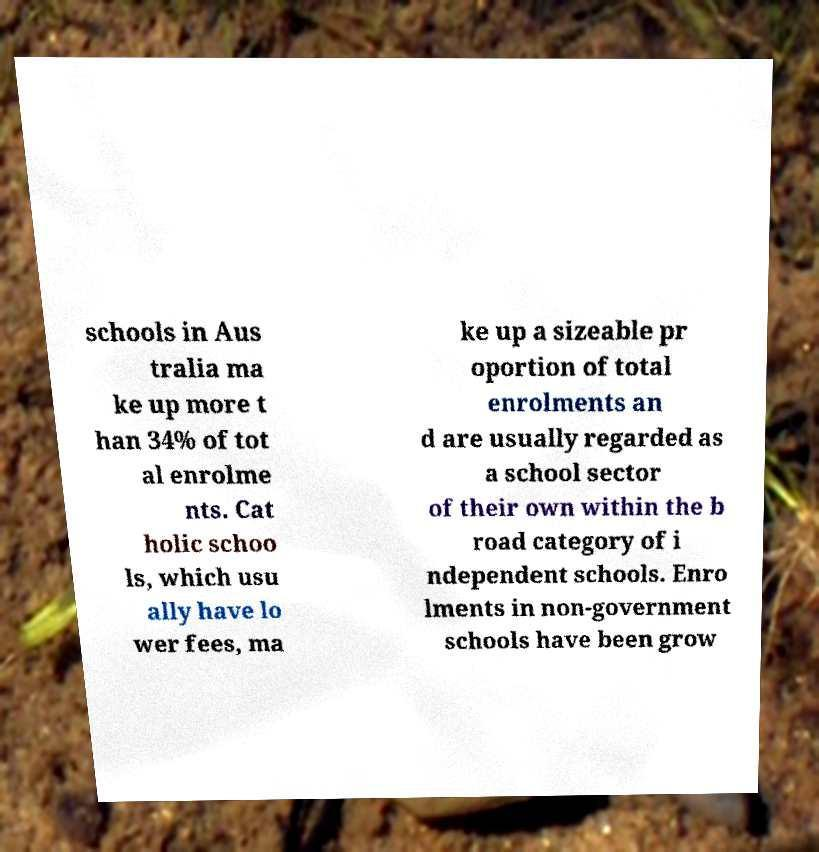What messages or text are displayed in this image? I need them in a readable, typed format. schools in Aus tralia ma ke up more t han 34% of tot al enrolme nts. Cat holic schoo ls, which usu ally have lo wer fees, ma ke up a sizeable pr oportion of total enrolments an d are usually regarded as a school sector of their own within the b road category of i ndependent schools. Enro lments in non-government schools have been grow 